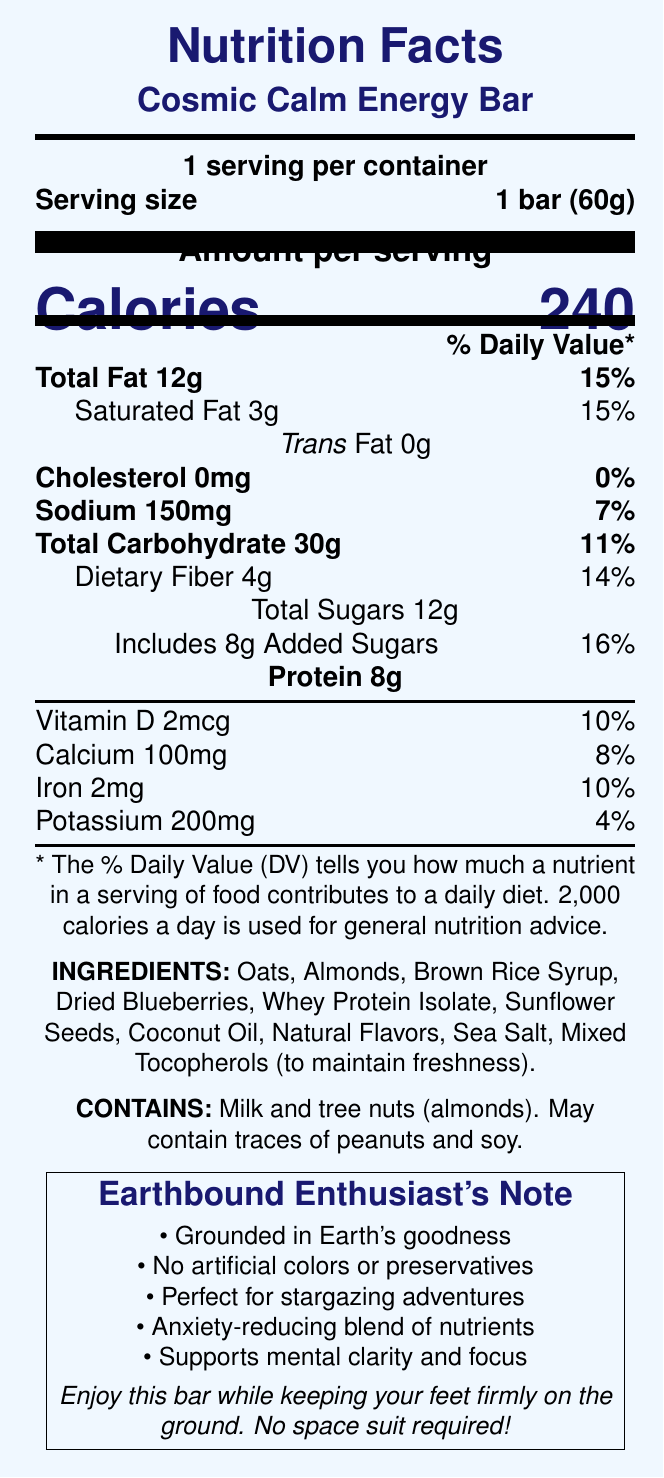What is the serving size of the Cosmic Calm Energy Bar? The serving size is explicitly mentioned as "1 bar (60g)" in the document.
Answer: 1 bar (60g) How many calories are in one serving of the Cosmic Calm Energy Bar? The document states that there are 240 calories per serving.
Answer: 240 calories What percentage of the Daily Value of Total Fat does one bar provide? The document indicates that one bar contains 12g of Total Fat, which covers 15% of the Daily Value.
Answer: 15% How much dietary fiber does the Cosmic Calm Energy Bar contain? The bar contains 4g of dietary fiber, as noted in the document.
Answer: 4g Which added nutrients support mental clarity and focus? The document mentions that the bar is enriched with these specific nutrients to support mental clarity and focus.
Answer: L-theanine, chamomile extract, B-complex vitamins, magnesium What are the main contributing ingredients that may cause allergies? The allergen information specifies that the bar contains milk and tree nuts (almonds).
Answer: Milk and tree nuts (almonds) What special feature helps in stress relief? The document lists “Contains L-theanine for stress relief” as one of the special features.
Answer: Contains L-theanine Is the Cosmic Calm Energy Bar suitable for someone who avoids artificial preservatives? The document claims "No artificial colors or preservatives" under the marketing claims.
Answer: Yes Which nutrient has the highest percentage of Daily Value per serving? The document mentions that added sugars are 8g, providing 16% of the Daily Value, which is the highest percentage among the listed nutrients.
Answer: Added Sugars Does the Cosmic Calm Energy Bar require a space suit for consumption? The consumption instructions clearly state that no space suit is required.
Answer: No How many grams of protein are in the Cosmic Calm Energy Bar? The document lists the protein content as 8g.
Answer: 8g Which of the following marketing claims is NOT mentioned in the document? A. Grounded in Earth's goodness B. Excellent source of Vitamin C C. Perfect for stargazing adventures The document does not list "Excellent source of Vitamin C" as a marketing claim.
Answer: B What is the total amount of sugars in the Cosmic Calm Energy Bar? The document mentions that the total sugars content is 12g.
Answer: 12g Which nutrient in the Cosmic Calm Energy Bar contributes to calming effects? A. Calcium B. Vitamin D C. Chamomile extract D. Iron The document indicates that chamomile extract is added for calmness.
Answer: C How much sodium is in the Cosmic Calm Energy Bar? The sodium content is listed as 150mg in the document.
Answer: 150mg True or False: The Cosmic Calm Energy Bar contains artificial colors. The document claims "No artificial colors or preservatives" under the marketing claims.
Answer: False Summarize the key nutritional and marketing information provided about the Cosmic Calm Energy Bar. This answer follows the nutritional breakdown and marketing highlights mentioned in the document to provide a comprehensive summary.
Answer: The Cosmic Calm Energy Bar provides 240 calories per 60g serving and contains 12g of total fat, 30g of carbohydrates, including 4g of dietary fiber and 12g of sugars (8g from added sugars), and 8g of protein. It also includes various vitamins and minerals. The bar contains ingredients such as oats, almonds, brown rice syrup, and whey protein isolate and may cause allergies due to milk and tree nuts. Marketing claims highlight its natural benefits, including stress relief and mental clarity, without artificial preservatives or colors. What is the main source of sweetness in the Cosmic Calm Energy Bar? The ingredients list mentions brown rice syrup, which is commonly used as a sweetener.
Answer: Brown Rice Syrup Can you determine the manufacturing location of the Cosmic Calm Energy Bar from the document? The document does not provide any information regarding the manufacturing location.
Answer: Cannot be determined 